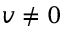Convert formula to latex. <formula><loc_0><loc_0><loc_500><loc_500>v \neq 0</formula> 